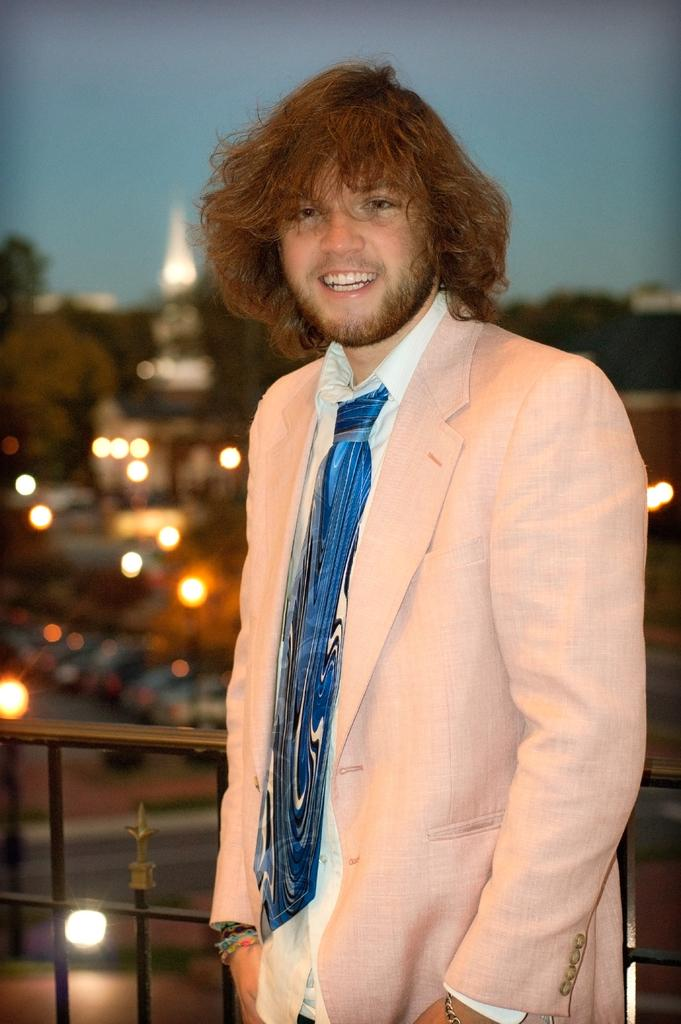What is the main subject of the image? There is a person in the image. What is the person wearing? The person is wearing a suit. What is the person doing in the image? The person is standing and posing for a photograph. Can you describe the background of the image? The background of the image is blurry. What type of cover is on the goat in the image? There is no goat present in the image, and therefore no cover on a goat can be observed. 